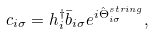Convert formula to latex. <formula><loc_0><loc_0><loc_500><loc_500>c _ { i \sigma } = h _ { i } ^ { \dagger } \bar { b } _ { i \sigma } e ^ { i \hat { \Theta } ^ { s t r i n g } _ { i \sigma } } ,</formula> 